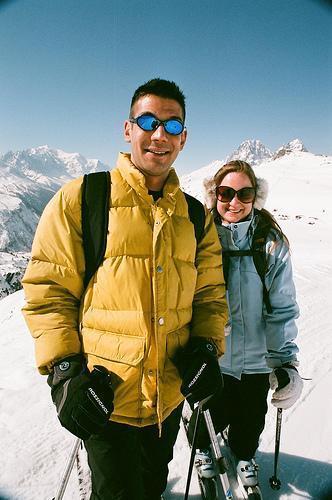How many people are reading book?
Give a very brief answer. 0. How many people are wearing a yellow jacket?
Give a very brief answer. 1. 